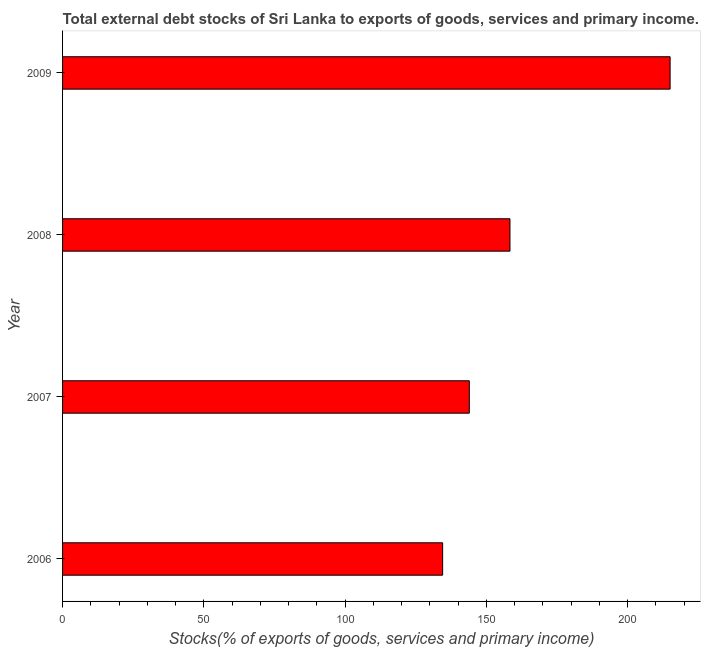Does the graph contain any zero values?
Make the answer very short. No. Does the graph contain grids?
Your answer should be very brief. No. What is the title of the graph?
Keep it short and to the point. Total external debt stocks of Sri Lanka to exports of goods, services and primary income. What is the label or title of the X-axis?
Offer a very short reply. Stocks(% of exports of goods, services and primary income). What is the external debt stocks in 2009?
Keep it short and to the point. 215.05. Across all years, what is the maximum external debt stocks?
Your response must be concise. 215.05. Across all years, what is the minimum external debt stocks?
Give a very brief answer. 134.53. What is the sum of the external debt stocks?
Provide a succinct answer. 651.92. What is the difference between the external debt stocks in 2006 and 2007?
Offer a terse response. -9.44. What is the average external debt stocks per year?
Provide a short and direct response. 162.98. What is the median external debt stocks?
Provide a succinct answer. 151.17. What is the ratio of the external debt stocks in 2007 to that in 2009?
Provide a succinct answer. 0.67. What is the difference between the highest and the second highest external debt stocks?
Your response must be concise. 56.69. What is the difference between the highest and the lowest external debt stocks?
Ensure brevity in your answer.  80.52. How many years are there in the graph?
Your answer should be very brief. 4. What is the Stocks(% of exports of goods, services and primary income) in 2006?
Make the answer very short. 134.53. What is the Stocks(% of exports of goods, services and primary income) in 2007?
Provide a succinct answer. 143.97. What is the Stocks(% of exports of goods, services and primary income) in 2008?
Offer a terse response. 158.36. What is the Stocks(% of exports of goods, services and primary income) in 2009?
Your answer should be very brief. 215.05. What is the difference between the Stocks(% of exports of goods, services and primary income) in 2006 and 2007?
Your answer should be very brief. -9.44. What is the difference between the Stocks(% of exports of goods, services and primary income) in 2006 and 2008?
Your answer should be compact. -23.83. What is the difference between the Stocks(% of exports of goods, services and primary income) in 2006 and 2009?
Provide a short and direct response. -80.52. What is the difference between the Stocks(% of exports of goods, services and primary income) in 2007 and 2008?
Give a very brief answer. -14.39. What is the difference between the Stocks(% of exports of goods, services and primary income) in 2007 and 2009?
Keep it short and to the point. -71.08. What is the difference between the Stocks(% of exports of goods, services and primary income) in 2008 and 2009?
Make the answer very short. -56.69. What is the ratio of the Stocks(% of exports of goods, services and primary income) in 2006 to that in 2007?
Make the answer very short. 0.93. What is the ratio of the Stocks(% of exports of goods, services and primary income) in 2006 to that in 2009?
Make the answer very short. 0.63. What is the ratio of the Stocks(% of exports of goods, services and primary income) in 2007 to that in 2008?
Your response must be concise. 0.91. What is the ratio of the Stocks(% of exports of goods, services and primary income) in 2007 to that in 2009?
Keep it short and to the point. 0.67. What is the ratio of the Stocks(% of exports of goods, services and primary income) in 2008 to that in 2009?
Offer a very short reply. 0.74. 